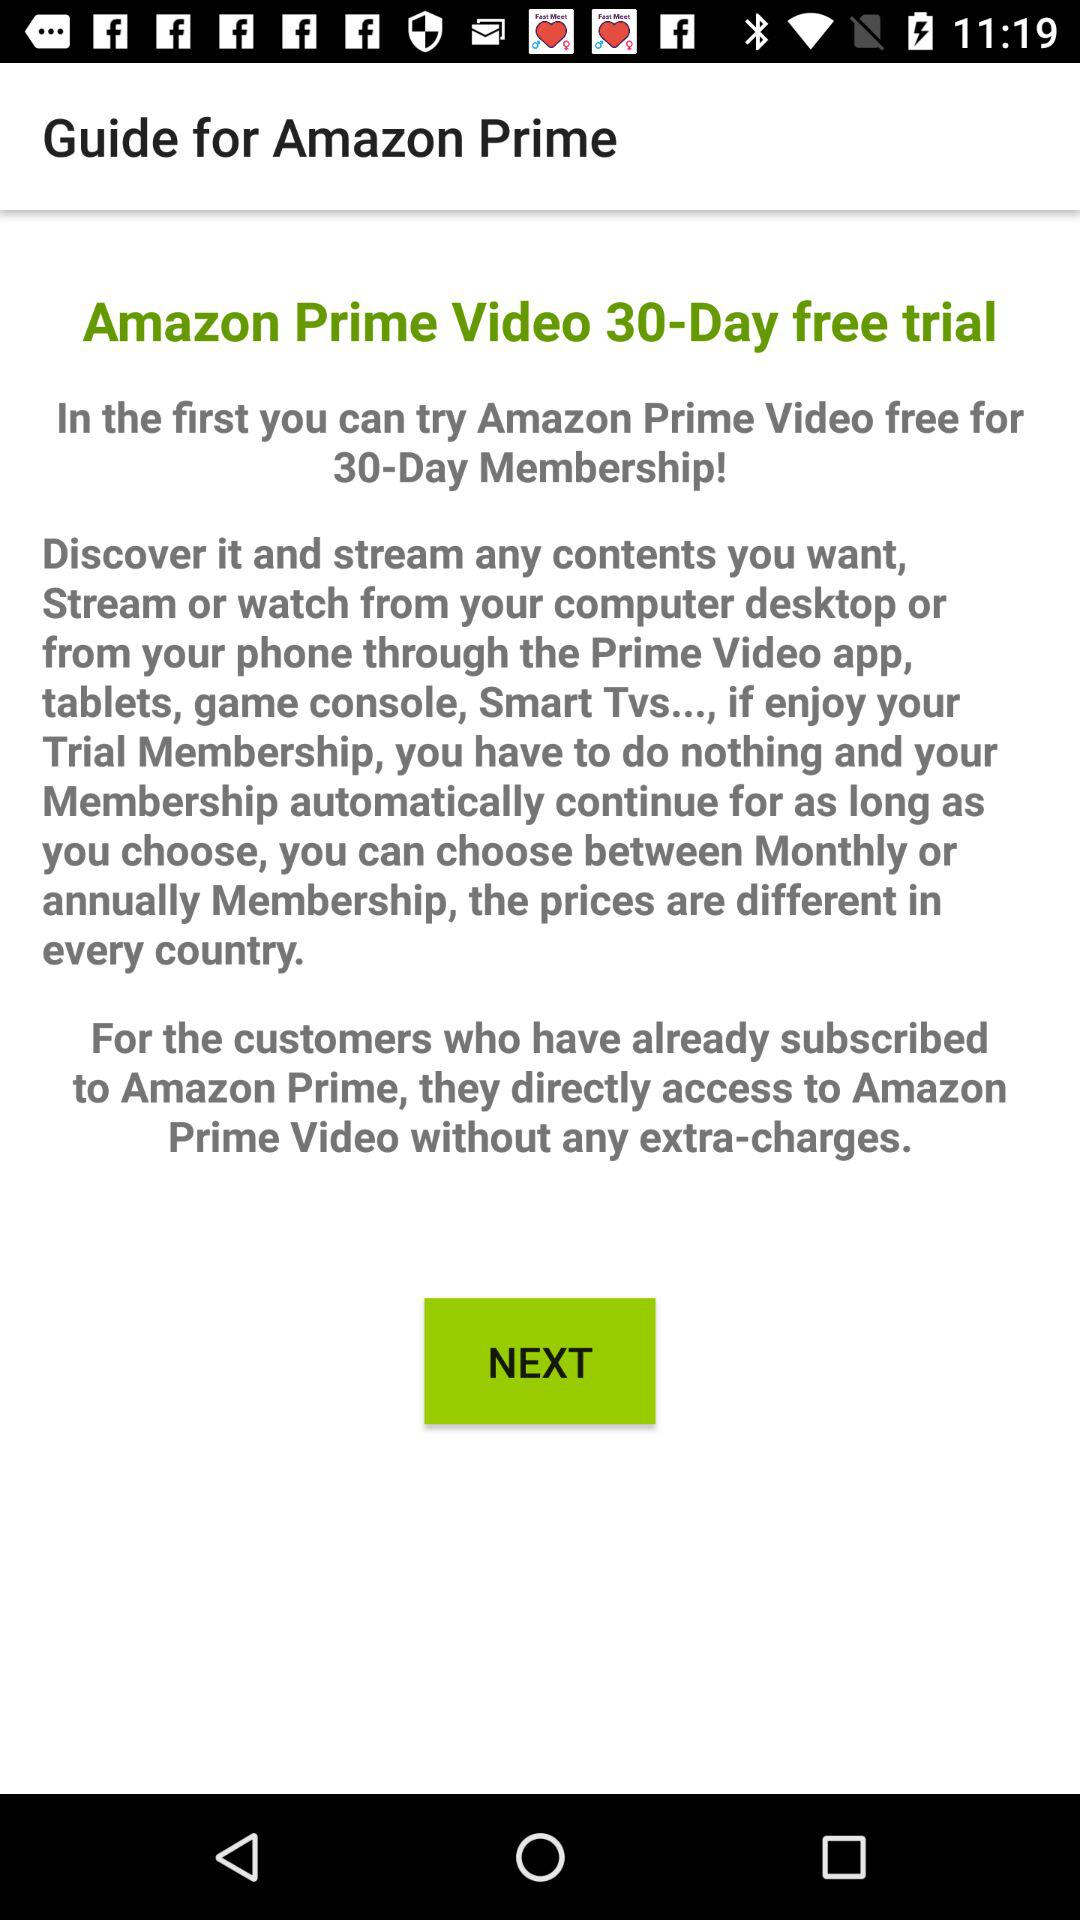What is the application name? The application name is "Guide for Amazon Prime". 